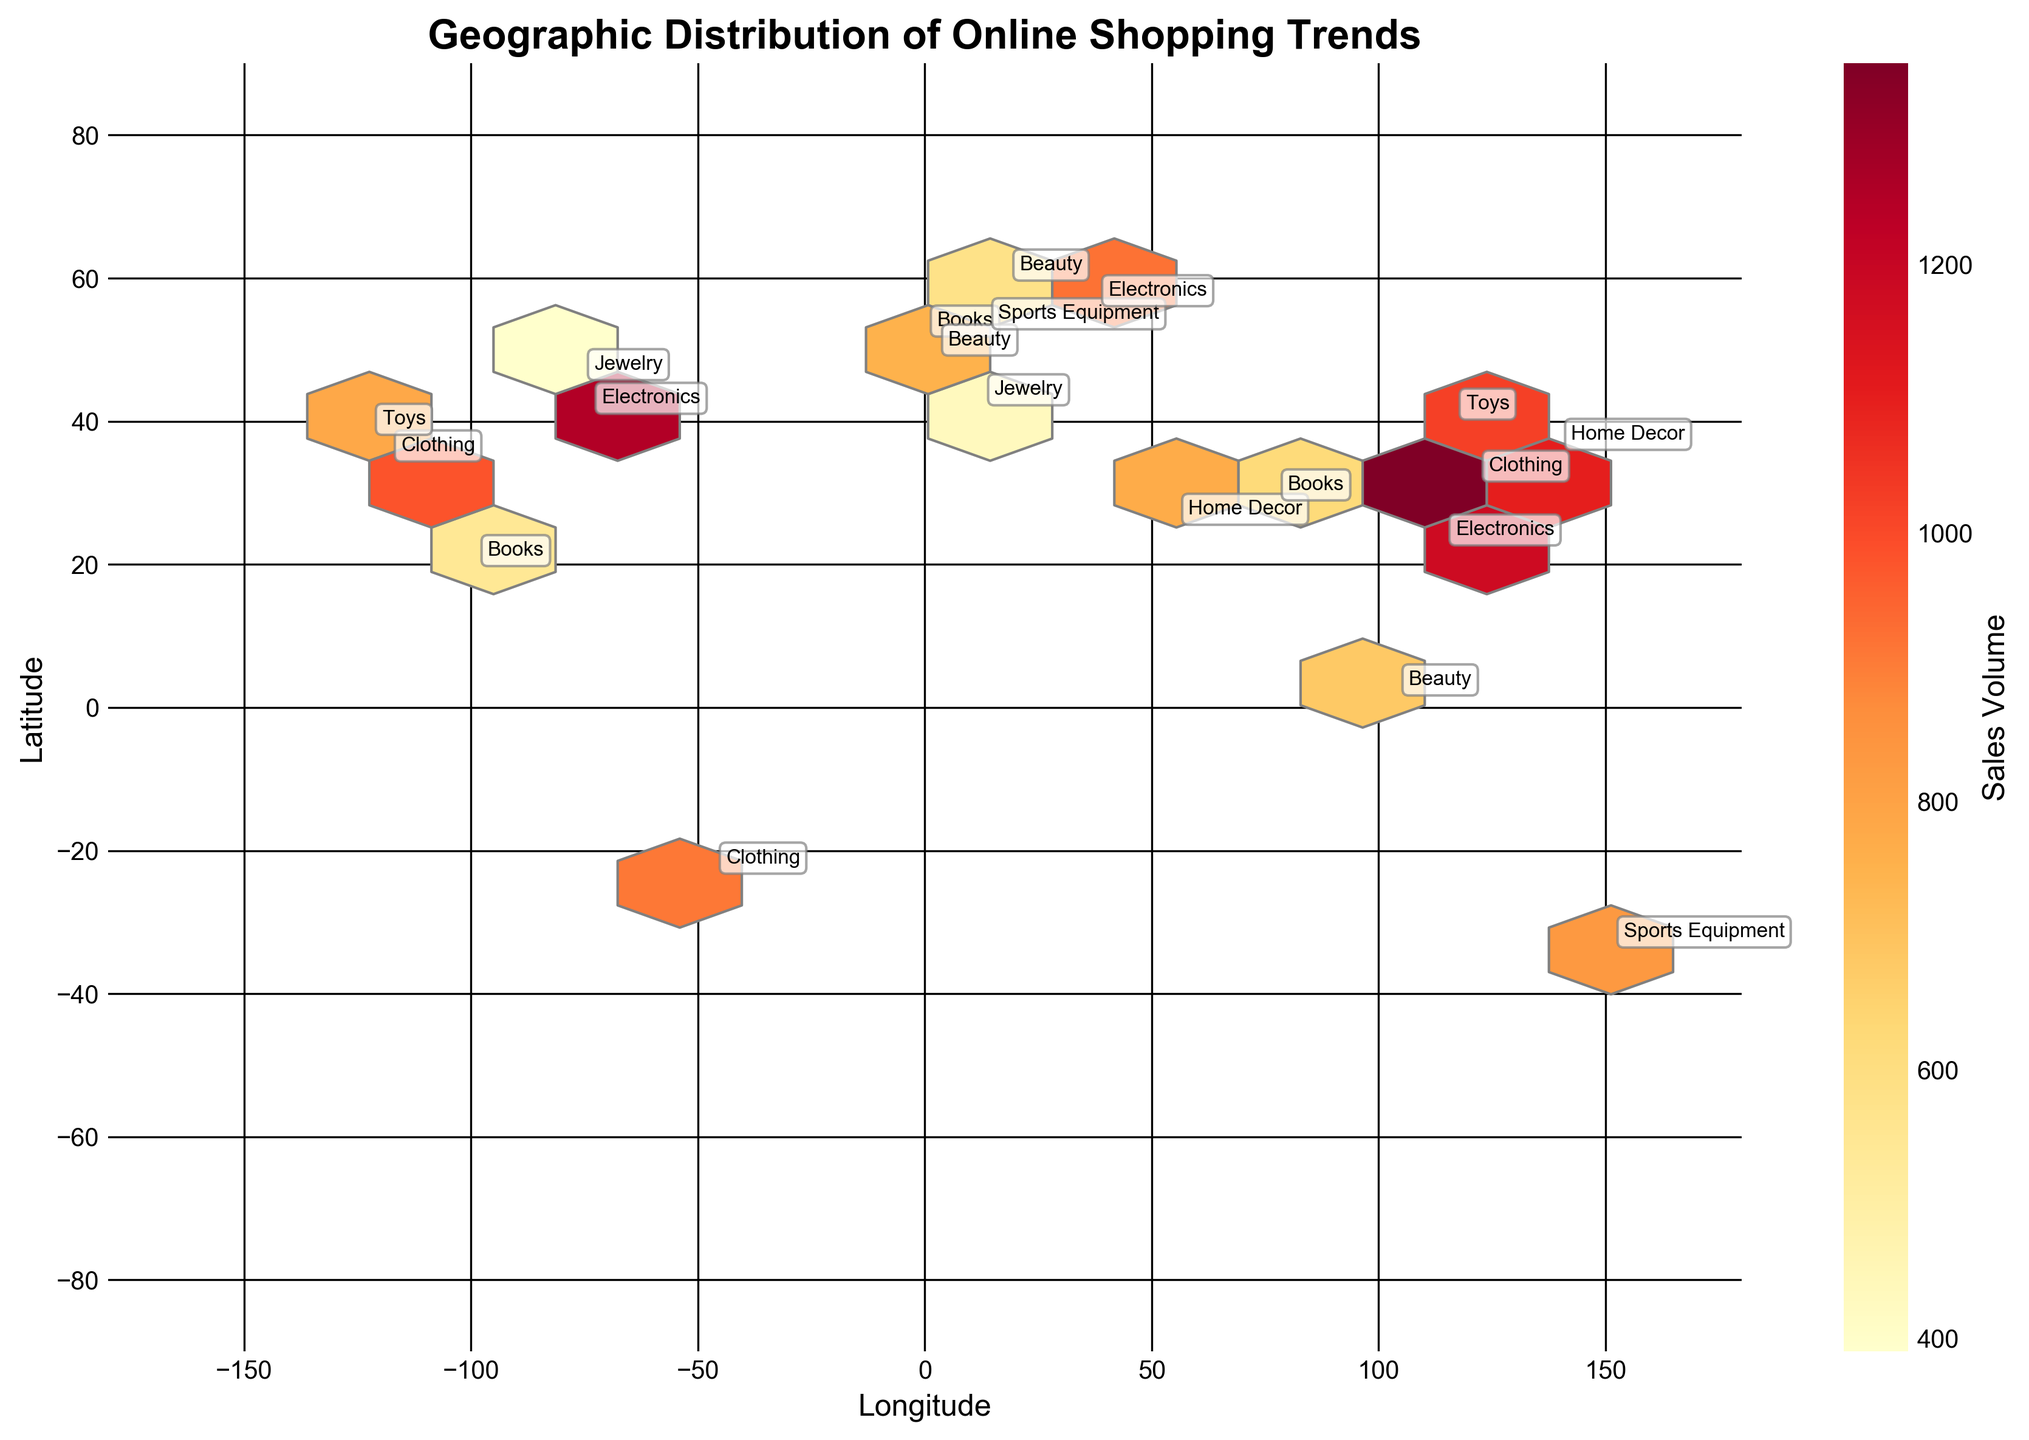What is the title of the plot? The title is often found at the top of the plot, describing the main subject or purpose of the visualization. In this case, it reads 'Geographic Distribution of Online Shopping Trends'.
Answer: Geographic Distribution of Online Shopping Trends How many product categories are labeled on the plot? Look for unique labels on the plot, associated with each hexbin. The categories are Electronics, Clothing, Books, Beauty, Home Decor, Sports Equipment, Jewelry, and Toys, totaling to 8 different categories.
Answer: 8 Which product category has the highest sales volume in winter? Identify the hexagons and labels for the Winter season, and check the sales volume associated with each category. The highest value visible for Winter is 980 (Clothing in Los Angeles).
Answer: Clothing What is the rough grid size used for the hexbin plot? The grid size of a hexbin plot refers to the number of hexagons along each axis. Observing the density of hexagons across the plot, it looks like approximately 10 hexagons are along each axis.
Answer: 10 Which city has the highest sales volume for Electronics? Locate all the hexbins labeled 'Electronics' and compare their sales volumes. Hong Kong has the highest sales volume of 1180 for Electronics.
Answer: Hong Kong Which product category has the smallest sales volume in any season? Look for all product categories across all seasons and find the minimum sales volume. Jewelry in Winter (Ottawa) has the smallest sales volume of 390.
Answer: Jewelry What season does Paris have the highest sales volume in? Find the location of Paris on the plot and check the associated sales volume and season label. Paris (latitude 48.8566, longitude 2.3522) has a highest sales volume in Fall with 890.
Answer: Fall Compare the sales volume of Toys in Winter and Spring. Which season has higher sales? Locate the hexbins labeled 'Toys' for Winter and Spring, and check their sales volumes. Winter has a sales volume of 780 (San Francisco) and Spring has 1020 (Beijing), so Spring has higher sales.
Answer: Spring What is the color range used to indicate sales volume? Observe the colorbar denoting sales volume. The color range varies from light yellow to dark red, with darker colors indicating higher sales volume.
Answer: Light yellow to dark red Which continent appears to have the most diverse range of product categories based on the plot? Judge based on the number of different category labels present on each continent. Europe has Electronics (London, Moscow), Books (London), Beauty (Paris, Stockholm), Jewelry (Rome), Sports Equipment (Berlin), totaling to 5 categories, seemingly the most diverse.
Answer: Europe 